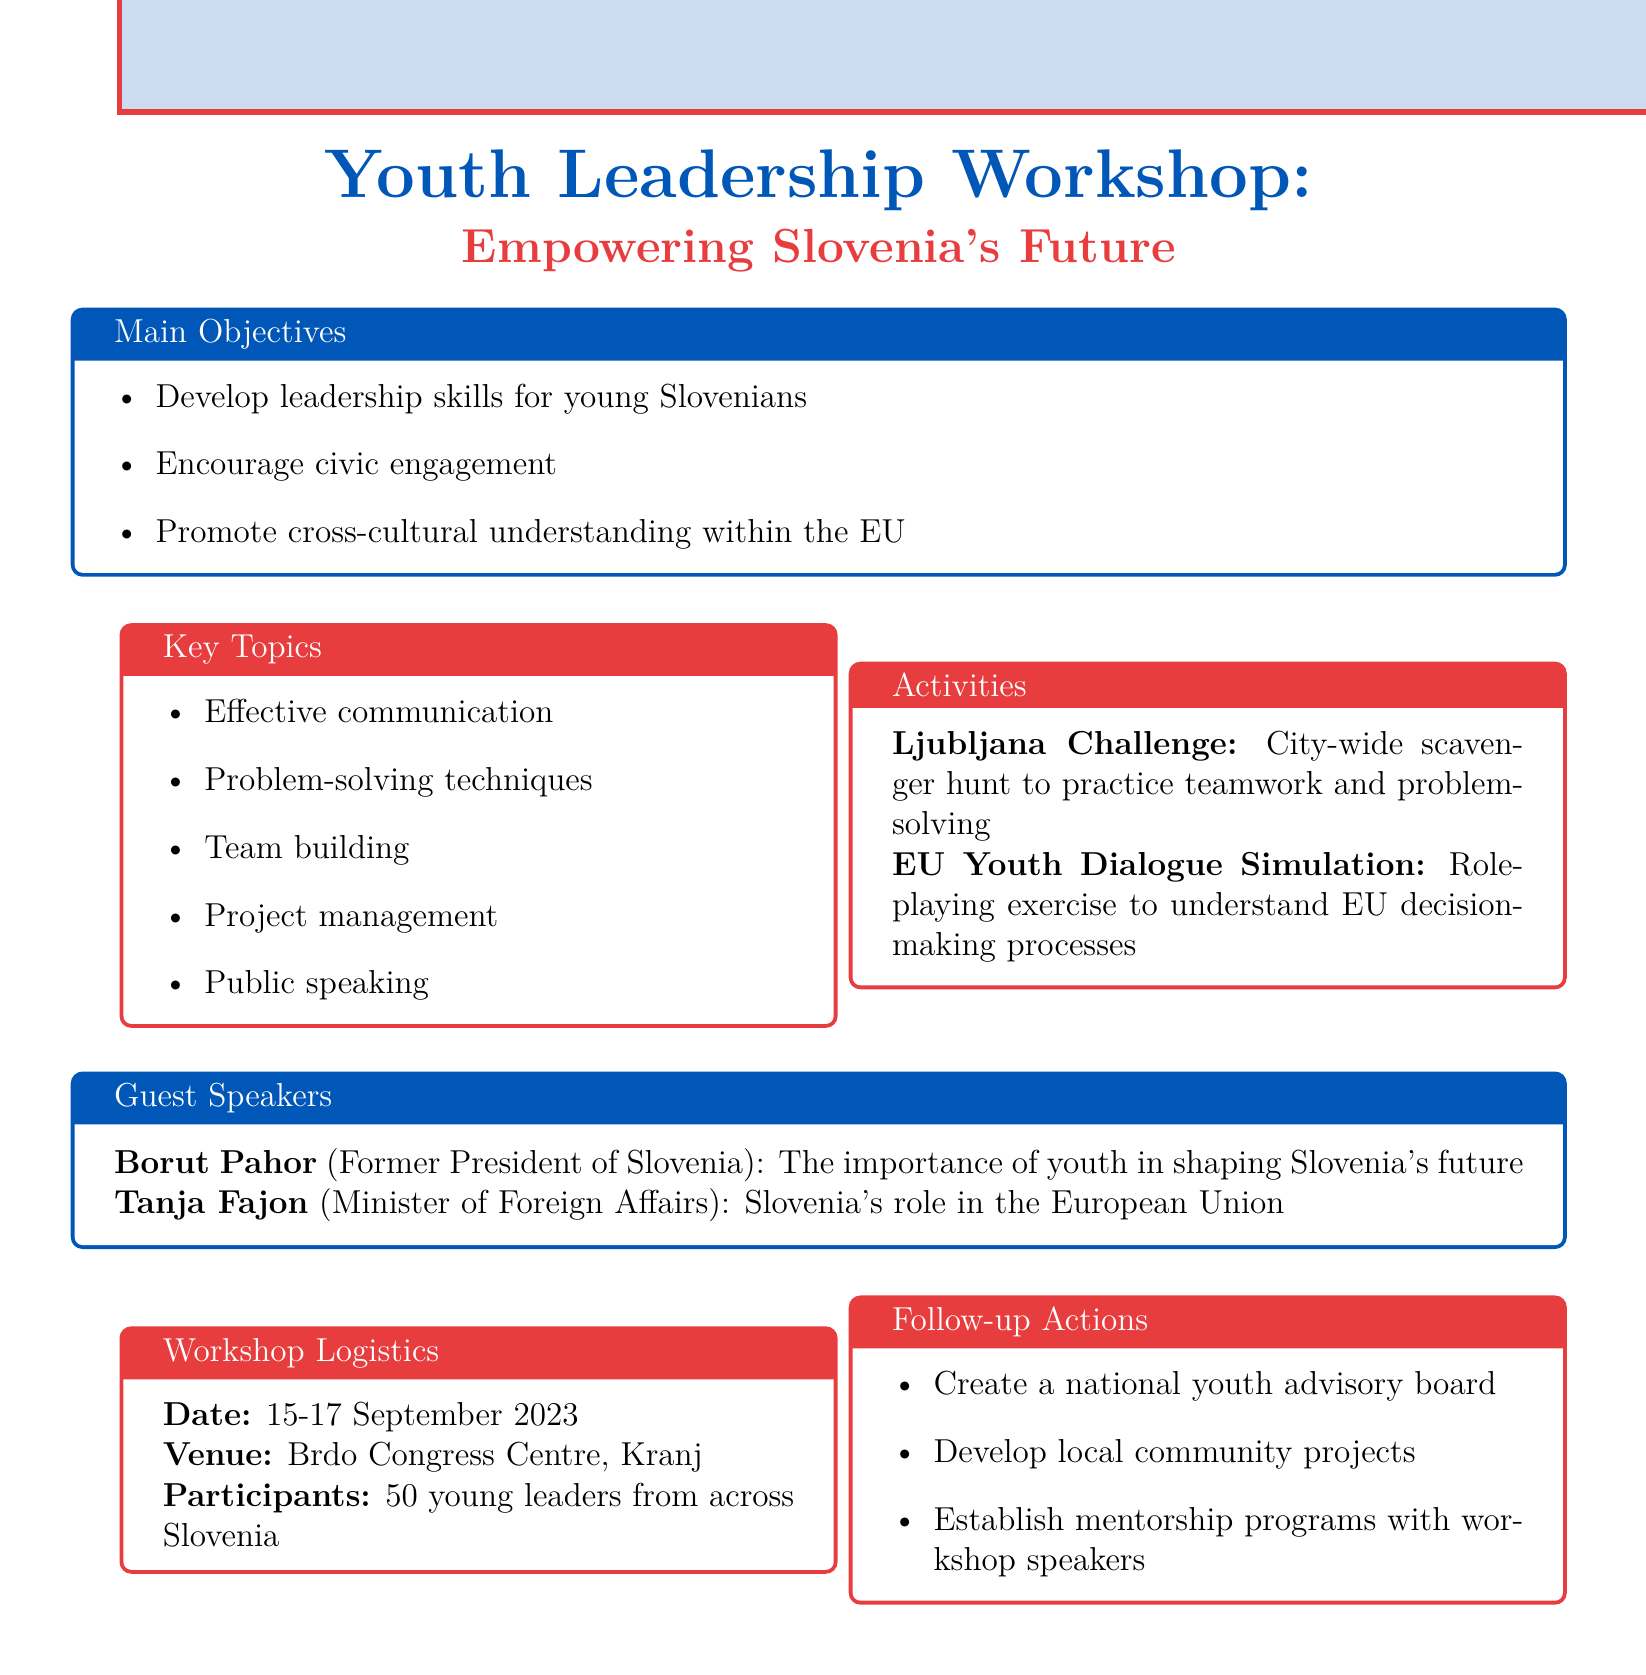What is the title of the workshop? The title of the workshop is found at the beginning of the document, which specifies the event's name.
Answer: Youth Leadership Workshop: Empowering Slovenia's Future When is the workshop scheduled? The schedule for the workshop is listed in the logistics section of the document, detailing the specific dates.
Answer: 15-17 September 2023 Where will the workshop take place? The venue for the workshop is indicated in the logistics section, providing the location of the event.
Answer: Brdo Congress Centre, Kranj Who is a guest speaker at the workshop? The document mentions notable speakers, where both are listed under the guest speakers section.
Answer: Borut Pahor What is one of the main objectives of the workshop? The main objectives are listed in their own section, showcasing key goals for the event.
Answer: Develop leadership skills for young Slovenians What is the number of participants expected? The total number of participants is specified in the logistics section of the document, indicating the scale of the event.
Answer: 50 young leaders What activity involves teamwork and problem-solving? The activities section describes two main activities, one of which focuses on teamwork and problem-solving.
Answer: Ljubljana Challenge What follow-up action includes mentorship? The follow-up actions detail specific steps to be taken after the workshop, one of which relates to mentorship opportunities.
Answer: Establish mentorship programs with workshop speakers What key topic pertains to EU decision-making? The key topics highlight various subjects, and one topic specifically relates to understanding EU processes.
Answer: Problem-solving techniques 